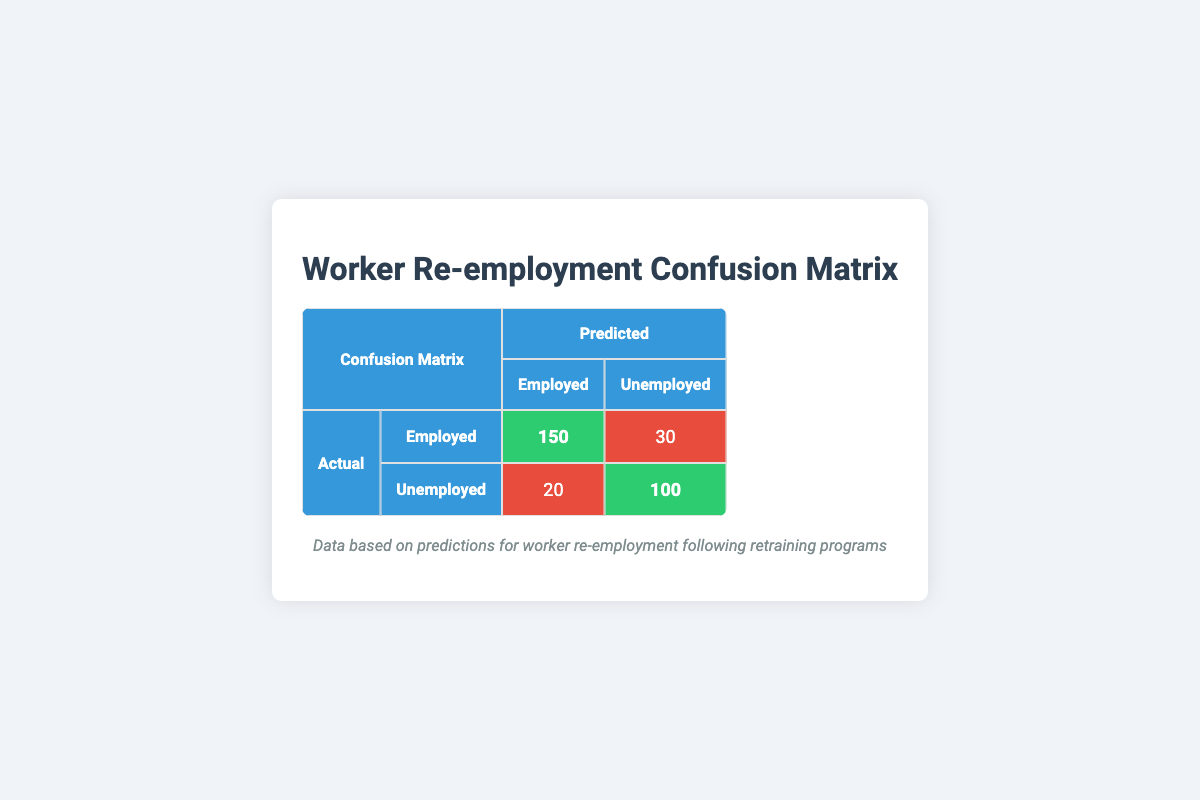What is the number of workers who were predicted to be employed and actually were employed? From the table, the count for workers predicted to be employed and actually employed is represented in the first row under "Predicted" and "Employed." The value is 150.
Answer: 150 How many workers were incorrectly predicted to be unemployed? To find the number of workers incorrectly predicted to be unemployed, look at the row for "Actual Employed" and see the count under "Predicted Unemployed," which is 30.
Answer: 30 What is the total number of employed workers, both predicted and actual? The total number of employed workers includes those actually employed (150) and those incorrectly predicted to be unemployed (20). Adding those gives 150 + 20 = 170.
Answer: 170 Did more workers actually remain unemployed than were mistakenly predicted to be employed? In the table, the number of actual unemployed workers is 100, and the number of workers incorrectly predicted to be employed is 20. Since 100 is greater than 20, the statement is true.
Answer: Yes What percentage of workers who were predicted to be unemployed actually were unemployed? The number of workers predicted to be unemployed is the sum of actual unemployed, which is 100, and those incorrectly predicted to be unemployed, which is 20. Thus, the percentage is (100 / (100 + 20)) * 100 = 83.33%.
Answer: 83.33% What is the total number of predictions made? To find the total number of predictions, add all counts from both actual categories. Thus, 150 + 30 + 20 + 100 = 300.
Answer: 300 What is the accuracy of the predictions? Accuracy is calculated by taking the sum of true positives and true negatives divided by the total predictions: (150 + 100) / 300 = 0.8333, or 83.33%.
Answer: 83.33% How many workers were correctly classified as unemployed? The correct classification of unemployed workers can be found in the row for "Unemployed" under "Predicted" where it says "Unemployed." Thus, the answer is 100.
Answer: 100 What is the difference between the number of true positives and false negatives? True positives (workers correctly predicted as employed) are 150, while false negatives (workers actually employed but predicted as unemployed) are 20. The difference is 150 - 20 = 130.
Answer: 130 